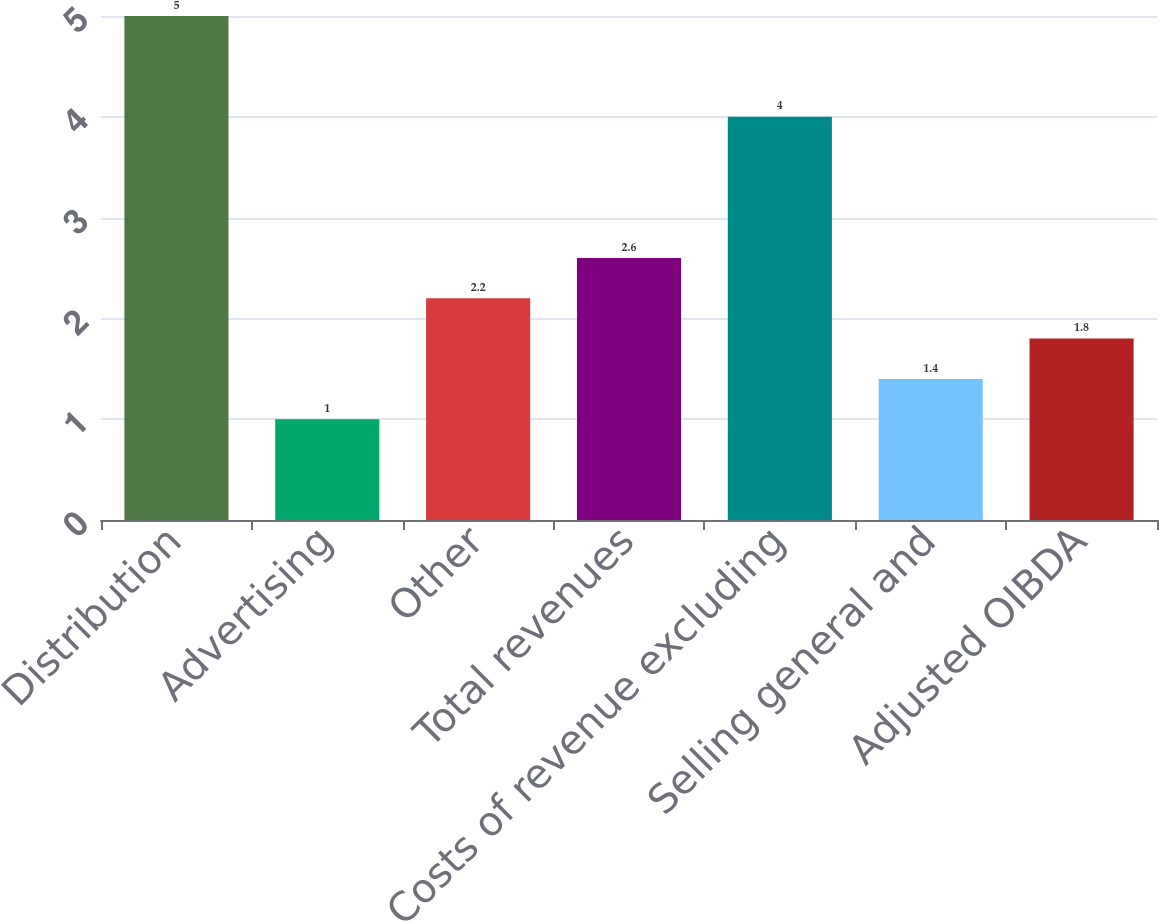Convert chart. <chart><loc_0><loc_0><loc_500><loc_500><bar_chart><fcel>Distribution<fcel>Advertising<fcel>Other<fcel>Total revenues<fcel>Costs of revenue excluding<fcel>Selling general and<fcel>Adjusted OIBDA<nl><fcel>5<fcel>1<fcel>2.2<fcel>2.6<fcel>4<fcel>1.4<fcel>1.8<nl></chart> 